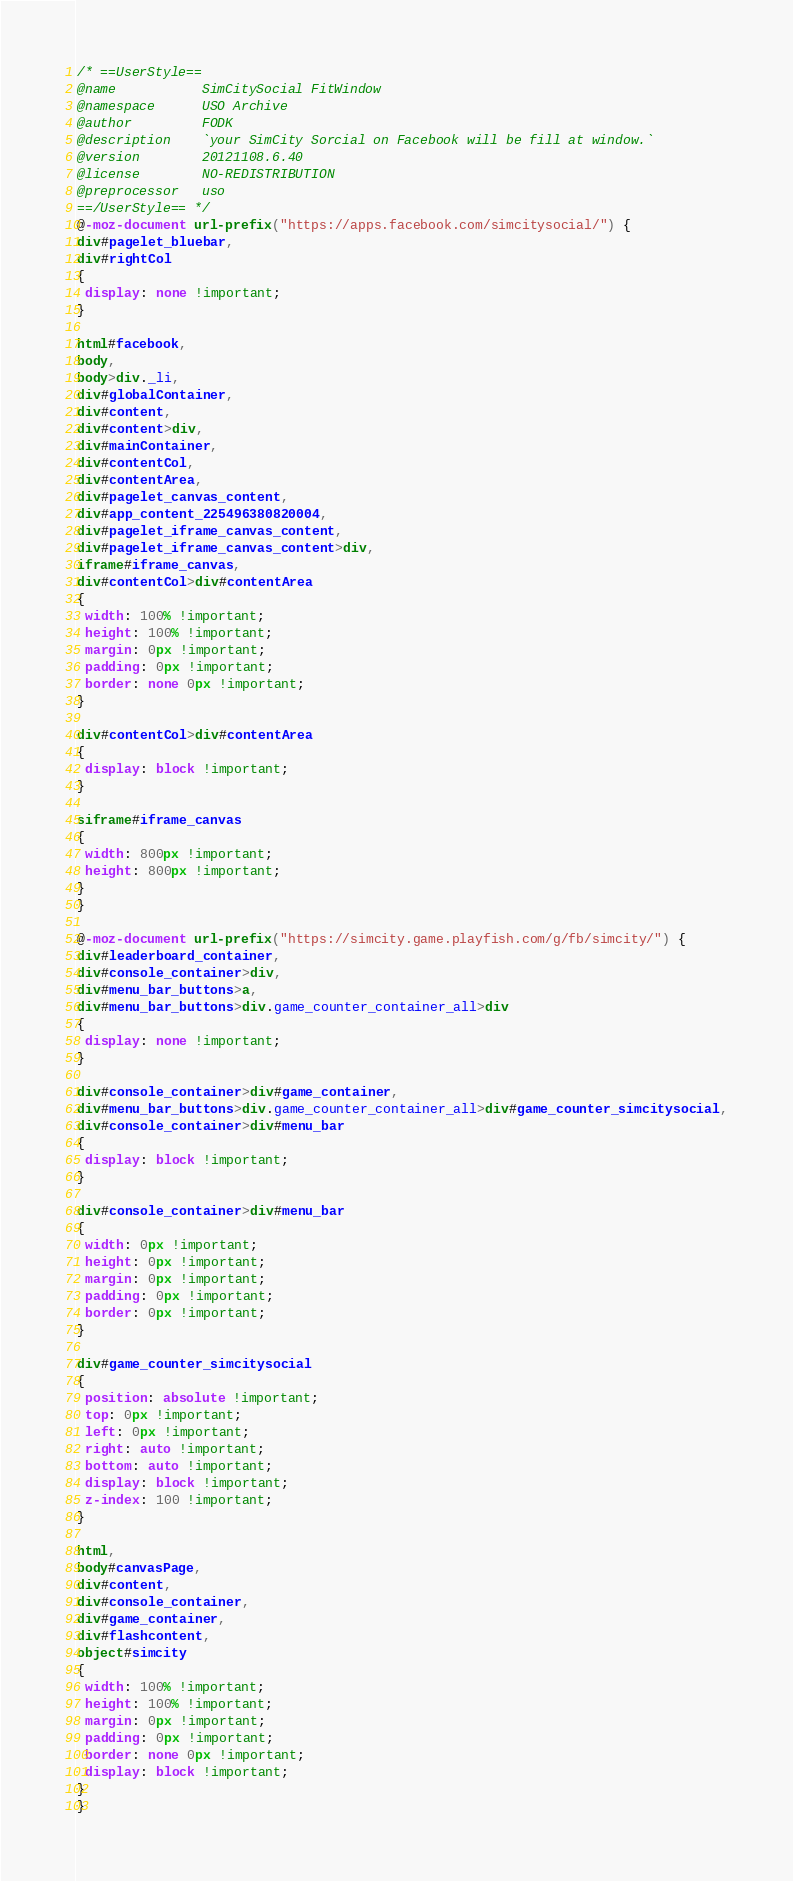Convert code to text. <code><loc_0><loc_0><loc_500><loc_500><_CSS_>/* ==UserStyle==
@name           SimCitySocial FitWindow
@namespace      USO Archive
@author         FODK
@description    `your SimCity Sorcial on Facebook will be fill at window.`
@version        20121108.6.40
@license        NO-REDISTRIBUTION
@preprocessor   uso
==/UserStyle== */
@-moz-document url-prefix("https://apps.facebook.com/simcitysocial/") {
div#pagelet_bluebar,
div#rightCol
{
 display: none !important;
}

html#facebook,
body,
body>div._li,
div#globalContainer,
div#content,
div#content>div,
div#mainContainer,
div#contentCol,
div#contentArea,
div#pagelet_canvas_content,
div#app_content_225496380820004,
div#pagelet_iframe_canvas_content,
div#pagelet_iframe_canvas_content>div,
iframe#iframe_canvas,
div#contentCol>div#contentArea
{
 width: 100% !important;
 height: 100% !important;
 margin: 0px !important;
 padding: 0px !important;
 border: none 0px !important;
}

div#contentCol>div#contentArea
{
 display: block !important;
}

siframe#iframe_canvas
{
 width: 800px !important;
 height: 800px !important;
}
}

@-moz-document url-prefix("https://simcity.game.playfish.com/g/fb/simcity/") {
div#leaderboard_container,
div#console_container>div,
div#menu_bar_buttons>a,
div#menu_bar_buttons>div.game_counter_container_all>div
{
 display: none !important;
}

div#console_container>div#game_container,
div#menu_bar_buttons>div.game_counter_container_all>div#game_counter_simcitysocial,
div#console_container>div#menu_bar
{
 display: block !important;
}

div#console_container>div#menu_bar
{
 width: 0px !important;
 height: 0px !important;
 margin: 0px !important;
 padding: 0px !important;
 border: 0px !important;
}

div#game_counter_simcitysocial
{
 position: absolute !important;
 top: 0px !important;
 left: 0px !important;
 right: auto !important;
 bottom: auto !important;
 display: block !important;
 z-index: 100 !important;
}

html,
body#canvasPage,
div#content,
div#console_container,
div#game_container,
div#flashcontent,
object#simcity
{
 width: 100% !important;
 height: 100% !important;
 margin: 0px !important;
 padding: 0px !important;
 border: none 0px !important;
 display: block !important;
}
}</code> 